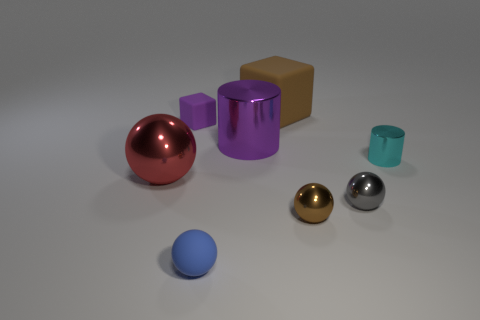Subtract 1 spheres. How many spheres are left? 3 Add 2 small rubber spheres. How many objects exist? 10 Subtract all cyan spheres. Subtract all purple cubes. How many spheres are left? 4 Subtract all cubes. How many objects are left? 6 Subtract 1 purple cylinders. How many objects are left? 7 Subtract all tiny brown balls. Subtract all large purple cylinders. How many objects are left? 6 Add 3 tiny cyan objects. How many tiny cyan objects are left? 4 Add 1 brown matte cylinders. How many brown matte cylinders exist? 1 